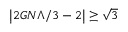Convert formula to latex. <formula><loc_0><loc_0><loc_500><loc_500>\left | 2 G N \Lambda / 3 - 2 \right | \geq \sqrt { 3 }</formula> 